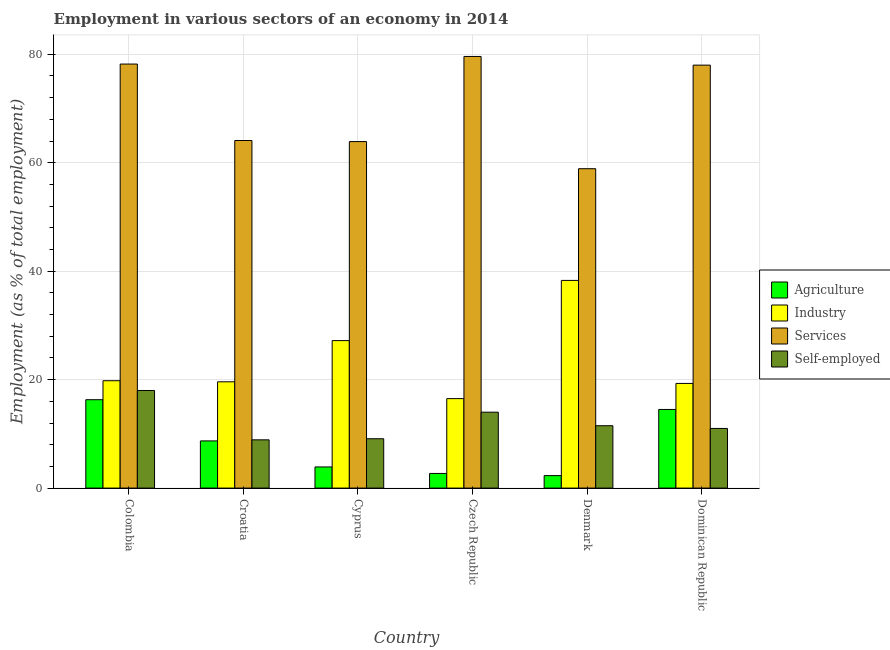How many groups of bars are there?
Provide a succinct answer. 6. Are the number of bars on each tick of the X-axis equal?
Make the answer very short. Yes. What is the label of the 3rd group of bars from the left?
Keep it short and to the point. Cyprus. In how many cases, is the number of bars for a given country not equal to the number of legend labels?
Keep it short and to the point. 0. Across all countries, what is the minimum percentage of workers in industry?
Your response must be concise. 16.5. In which country was the percentage of workers in agriculture maximum?
Make the answer very short. Colombia. In which country was the percentage of workers in industry minimum?
Provide a short and direct response. Czech Republic. What is the total percentage of workers in industry in the graph?
Offer a terse response. 140.7. What is the difference between the percentage of self employed workers in Cyprus and that in Denmark?
Make the answer very short. -2.4. What is the difference between the percentage of workers in services in Cyprus and the percentage of self employed workers in Czech Republic?
Make the answer very short. 49.9. What is the average percentage of workers in industry per country?
Offer a very short reply. 23.45. What is the difference between the percentage of self employed workers and percentage of workers in services in Czech Republic?
Your answer should be very brief. -65.6. In how many countries, is the percentage of workers in agriculture greater than 20 %?
Keep it short and to the point. 0. What is the ratio of the percentage of self employed workers in Cyprus to that in Czech Republic?
Offer a terse response. 0.65. Is the percentage of workers in industry in Czech Republic less than that in Dominican Republic?
Your answer should be compact. Yes. What is the difference between the highest and the second highest percentage of workers in agriculture?
Your response must be concise. 1.8. What is the difference between the highest and the lowest percentage of self employed workers?
Provide a short and direct response. 9.1. In how many countries, is the percentage of workers in services greater than the average percentage of workers in services taken over all countries?
Provide a succinct answer. 3. Is it the case that in every country, the sum of the percentage of workers in industry and percentage of workers in agriculture is greater than the sum of percentage of self employed workers and percentage of workers in services?
Provide a short and direct response. Yes. What does the 4th bar from the left in Denmark represents?
Offer a very short reply. Self-employed. What does the 4th bar from the right in Cyprus represents?
Your answer should be very brief. Agriculture. Is it the case that in every country, the sum of the percentage of workers in agriculture and percentage of workers in industry is greater than the percentage of workers in services?
Provide a succinct answer. No. How many bars are there?
Give a very brief answer. 24. Are all the bars in the graph horizontal?
Your answer should be very brief. No. How many countries are there in the graph?
Give a very brief answer. 6. What is the difference between two consecutive major ticks on the Y-axis?
Provide a succinct answer. 20. How many legend labels are there?
Keep it short and to the point. 4. How are the legend labels stacked?
Your answer should be compact. Vertical. What is the title of the graph?
Provide a succinct answer. Employment in various sectors of an economy in 2014. Does "UNPBF" appear as one of the legend labels in the graph?
Your response must be concise. No. What is the label or title of the X-axis?
Provide a short and direct response. Country. What is the label or title of the Y-axis?
Your response must be concise. Employment (as % of total employment). What is the Employment (as % of total employment) of Agriculture in Colombia?
Provide a succinct answer. 16.3. What is the Employment (as % of total employment) of Industry in Colombia?
Keep it short and to the point. 19.8. What is the Employment (as % of total employment) of Services in Colombia?
Your response must be concise. 78.2. What is the Employment (as % of total employment) in Self-employed in Colombia?
Offer a very short reply. 18. What is the Employment (as % of total employment) in Agriculture in Croatia?
Provide a succinct answer. 8.7. What is the Employment (as % of total employment) in Industry in Croatia?
Your answer should be very brief. 19.6. What is the Employment (as % of total employment) of Services in Croatia?
Give a very brief answer. 64.1. What is the Employment (as % of total employment) in Self-employed in Croatia?
Keep it short and to the point. 8.9. What is the Employment (as % of total employment) of Agriculture in Cyprus?
Make the answer very short. 3.9. What is the Employment (as % of total employment) in Industry in Cyprus?
Your response must be concise. 27.2. What is the Employment (as % of total employment) in Services in Cyprus?
Give a very brief answer. 63.9. What is the Employment (as % of total employment) of Self-employed in Cyprus?
Your answer should be very brief. 9.1. What is the Employment (as % of total employment) in Agriculture in Czech Republic?
Provide a succinct answer. 2.7. What is the Employment (as % of total employment) of Services in Czech Republic?
Give a very brief answer. 79.6. What is the Employment (as % of total employment) of Self-employed in Czech Republic?
Make the answer very short. 14. What is the Employment (as % of total employment) of Agriculture in Denmark?
Ensure brevity in your answer.  2.3. What is the Employment (as % of total employment) of Industry in Denmark?
Your response must be concise. 38.3. What is the Employment (as % of total employment) in Services in Denmark?
Offer a terse response. 58.9. What is the Employment (as % of total employment) in Self-employed in Denmark?
Your response must be concise. 11.5. What is the Employment (as % of total employment) of Industry in Dominican Republic?
Give a very brief answer. 19.3. What is the Employment (as % of total employment) of Services in Dominican Republic?
Your response must be concise. 78. What is the Employment (as % of total employment) of Self-employed in Dominican Republic?
Make the answer very short. 11. Across all countries, what is the maximum Employment (as % of total employment) of Agriculture?
Offer a terse response. 16.3. Across all countries, what is the maximum Employment (as % of total employment) of Industry?
Ensure brevity in your answer.  38.3. Across all countries, what is the maximum Employment (as % of total employment) of Services?
Your answer should be compact. 79.6. Across all countries, what is the maximum Employment (as % of total employment) in Self-employed?
Ensure brevity in your answer.  18. Across all countries, what is the minimum Employment (as % of total employment) in Agriculture?
Provide a short and direct response. 2.3. Across all countries, what is the minimum Employment (as % of total employment) in Services?
Your response must be concise. 58.9. Across all countries, what is the minimum Employment (as % of total employment) of Self-employed?
Give a very brief answer. 8.9. What is the total Employment (as % of total employment) of Agriculture in the graph?
Offer a very short reply. 48.4. What is the total Employment (as % of total employment) in Industry in the graph?
Your answer should be very brief. 140.7. What is the total Employment (as % of total employment) in Services in the graph?
Your response must be concise. 422.7. What is the total Employment (as % of total employment) of Self-employed in the graph?
Provide a short and direct response. 72.5. What is the difference between the Employment (as % of total employment) in Agriculture in Colombia and that in Croatia?
Offer a terse response. 7.6. What is the difference between the Employment (as % of total employment) of Agriculture in Colombia and that in Cyprus?
Give a very brief answer. 12.4. What is the difference between the Employment (as % of total employment) of Industry in Colombia and that in Cyprus?
Your response must be concise. -7.4. What is the difference between the Employment (as % of total employment) of Self-employed in Colombia and that in Cyprus?
Make the answer very short. 8.9. What is the difference between the Employment (as % of total employment) in Agriculture in Colombia and that in Czech Republic?
Make the answer very short. 13.6. What is the difference between the Employment (as % of total employment) of Services in Colombia and that in Czech Republic?
Provide a succinct answer. -1.4. What is the difference between the Employment (as % of total employment) in Agriculture in Colombia and that in Denmark?
Offer a terse response. 14. What is the difference between the Employment (as % of total employment) in Industry in Colombia and that in Denmark?
Provide a succinct answer. -18.5. What is the difference between the Employment (as % of total employment) in Services in Colombia and that in Denmark?
Keep it short and to the point. 19.3. What is the difference between the Employment (as % of total employment) of Agriculture in Colombia and that in Dominican Republic?
Provide a short and direct response. 1.8. What is the difference between the Employment (as % of total employment) in Industry in Colombia and that in Dominican Republic?
Make the answer very short. 0.5. What is the difference between the Employment (as % of total employment) of Self-employed in Colombia and that in Dominican Republic?
Your answer should be compact. 7. What is the difference between the Employment (as % of total employment) of Agriculture in Croatia and that in Cyprus?
Make the answer very short. 4.8. What is the difference between the Employment (as % of total employment) in Services in Croatia and that in Cyprus?
Provide a short and direct response. 0.2. What is the difference between the Employment (as % of total employment) of Self-employed in Croatia and that in Cyprus?
Provide a succinct answer. -0.2. What is the difference between the Employment (as % of total employment) of Services in Croatia and that in Czech Republic?
Provide a short and direct response. -15.5. What is the difference between the Employment (as % of total employment) of Self-employed in Croatia and that in Czech Republic?
Make the answer very short. -5.1. What is the difference between the Employment (as % of total employment) of Agriculture in Croatia and that in Denmark?
Offer a very short reply. 6.4. What is the difference between the Employment (as % of total employment) of Industry in Croatia and that in Denmark?
Offer a very short reply. -18.7. What is the difference between the Employment (as % of total employment) in Self-employed in Croatia and that in Denmark?
Provide a short and direct response. -2.6. What is the difference between the Employment (as % of total employment) of Agriculture in Cyprus and that in Czech Republic?
Keep it short and to the point. 1.2. What is the difference between the Employment (as % of total employment) in Industry in Cyprus and that in Czech Republic?
Provide a succinct answer. 10.7. What is the difference between the Employment (as % of total employment) of Services in Cyprus and that in Czech Republic?
Make the answer very short. -15.7. What is the difference between the Employment (as % of total employment) in Agriculture in Cyprus and that in Denmark?
Offer a very short reply. 1.6. What is the difference between the Employment (as % of total employment) in Services in Cyprus and that in Denmark?
Provide a succinct answer. 5. What is the difference between the Employment (as % of total employment) in Agriculture in Cyprus and that in Dominican Republic?
Your answer should be compact. -10.6. What is the difference between the Employment (as % of total employment) of Services in Cyprus and that in Dominican Republic?
Make the answer very short. -14.1. What is the difference between the Employment (as % of total employment) in Self-employed in Cyprus and that in Dominican Republic?
Offer a very short reply. -1.9. What is the difference between the Employment (as % of total employment) of Industry in Czech Republic and that in Denmark?
Your answer should be compact. -21.8. What is the difference between the Employment (as % of total employment) of Services in Czech Republic and that in Denmark?
Keep it short and to the point. 20.7. What is the difference between the Employment (as % of total employment) of Agriculture in Czech Republic and that in Dominican Republic?
Your answer should be very brief. -11.8. What is the difference between the Employment (as % of total employment) of Industry in Czech Republic and that in Dominican Republic?
Provide a succinct answer. -2.8. What is the difference between the Employment (as % of total employment) in Services in Czech Republic and that in Dominican Republic?
Provide a succinct answer. 1.6. What is the difference between the Employment (as % of total employment) in Self-employed in Czech Republic and that in Dominican Republic?
Keep it short and to the point. 3. What is the difference between the Employment (as % of total employment) in Agriculture in Denmark and that in Dominican Republic?
Keep it short and to the point. -12.2. What is the difference between the Employment (as % of total employment) in Services in Denmark and that in Dominican Republic?
Your answer should be very brief. -19.1. What is the difference between the Employment (as % of total employment) of Agriculture in Colombia and the Employment (as % of total employment) of Services in Croatia?
Give a very brief answer. -47.8. What is the difference between the Employment (as % of total employment) of Agriculture in Colombia and the Employment (as % of total employment) of Self-employed in Croatia?
Your answer should be compact. 7.4. What is the difference between the Employment (as % of total employment) of Industry in Colombia and the Employment (as % of total employment) of Services in Croatia?
Ensure brevity in your answer.  -44.3. What is the difference between the Employment (as % of total employment) in Industry in Colombia and the Employment (as % of total employment) in Self-employed in Croatia?
Provide a succinct answer. 10.9. What is the difference between the Employment (as % of total employment) of Services in Colombia and the Employment (as % of total employment) of Self-employed in Croatia?
Ensure brevity in your answer.  69.3. What is the difference between the Employment (as % of total employment) in Agriculture in Colombia and the Employment (as % of total employment) in Services in Cyprus?
Your response must be concise. -47.6. What is the difference between the Employment (as % of total employment) in Industry in Colombia and the Employment (as % of total employment) in Services in Cyprus?
Keep it short and to the point. -44.1. What is the difference between the Employment (as % of total employment) in Services in Colombia and the Employment (as % of total employment) in Self-employed in Cyprus?
Offer a very short reply. 69.1. What is the difference between the Employment (as % of total employment) of Agriculture in Colombia and the Employment (as % of total employment) of Industry in Czech Republic?
Your response must be concise. -0.2. What is the difference between the Employment (as % of total employment) in Agriculture in Colombia and the Employment (as % of total employment) in Services in Czech Republic?
Offer a terse response. -63.3. What is the difference between the Employment (as % of total employment) in Agriculture in Colombia and the Employment (as % of total employment) in Self-employed in Czech Republic?
Offer a terse response. 2.3. What is the difference between the Employment (as % of total employment) of Industry in Colombia and the Employment (as % of total employment) of Services in Czech Republic?
Offer a terse response. -59.8. What is the difference between the Employment (as % of total employment) in Services in Colombia and the Employment (as % of total employment) in Self-employed in Czech Republic?
Offer a very short reply. 64.2. What is the difference between the Employment (as % of total employment) of Agriculture in Colombia and the Employment (as % of total employment) of Services in Denmark?
Provide a succinct answer. -42.6. What is the difference between the Employment (as % of total employment) of Industry in Colombia and the Employment (as % of total employment) of Services in Denmark?
Keep it short and to the point. -39.1. What is the difference between the Employment (as % of total employment) of Industry in Colombia and the Employment (as % of total employment) of Self-employed in Denmark?
Ensure brevity in your answer.  8.3. What is the difference between the Employment (as % of total employment) in Services in Colombia and the Employment (as % of total employment) in Self-employed in Denmark?
Your answer should be compact. 66.7. What is the difference between the Employment (as % of total employment) of Agriculture in Colombia and the Employment (as % of total employment) of Services in Dominican Republic?
Provide a short and direct response. -61.7. What is the difference between the Employment (as % of total employment) in Agriculture in Colombia and the Employment (as % of total employment) in Self-employed in Dominican Republic?
Offer a terse response. 5.3. What is the difference between the Employment (as % of total employment) of Industry in Colombia and the Employment (as % of total employment) of Services in Dominican Republic?
Your response must be concise. -58.2. What is the difference between the Employment (as % of total employment) of Industry in Colombia and the Employment (as % of total employment) of Self-employed in Dominican Republic?
Provide a short and direct response. 8.8. What is the difference between the Employment (as % of total employment) in Services in Colombia and the Employment (as % of total employment) in Self-employed in Dominican Republic?
Your answer should be compact. 67.2. What is the difference between the Employment (as % of total employment) of Agriculture in Croatia and the Employment (as % of total employment) of Industry in Cyprus?
Your answer should be compact. -18.5. What is the difference between the Employment (as % of total employment) in Agriculture in Croatia and the Employment (as % of total employment) in Services in Cyprus?
Provide a short and direct response. -55.2. What is the difference between the Employment (as % of total employment) of Industry in Croatia and the Employment (as % of total employment) of Services in Cyprus?
Your response must be concise. -44.3. What is the difference between the Employment (as % of total employment) of Industry in Croatia and the Employment (as % of total employment) of Self-employed in Cyprus?
Your response must be concise. 10.5. What is the difference between the Employment (as % of total employment) of Services in Croatia and the Employment (as % of total employment) of Self-employed in Cyprus?
Provide a succinct answer. 55. What is the difference between the Employment (as % of total employment) of Agriculture in Croatia and the Employment (as % of total employment) of Services in Czech Republic?
Your response must be concise. -70.9. What is the difference between the Employment (as % of total employment) of Agriculture in Croatia and the Employment (as % of total employment) of Self-employed in Czech Republic?
Offer a very short reply. -5.3. What is the difference between the Employment (as % of total employment) in Industry in Croatia and the Employment (as % of total employment) in Services in Czech Republic?
Make the answer very short. -60. What is the difference between the Employment (as % of total employment) of Services in Croatia and the Employment (as % of total employment) of Self-employed in Czech Republic?
Offer a very short reply. 50.1. What is the difference between the Employment (as % of total employment) of Agriculture in Croatia and the Employment (as % of total employment) of Industry in Denmark?
Offer a very short reply. -29.6. What is the difference between the Employment (as % of total employment) of Agriculture in Croatia and the Employment (as % of total employment) of Services in Denmark?
Your answer should be compact. -50.2. What is the difference between the Employment (as % of total employment) of Agriculture in Croatia and the Employment (as % of total employment) of Self-employed in Denmark?
Your response must be concise. -2.8. What is the difference between the Employment (as % of total employment) in Industry in Croatia and the Employment (as % of total employment) in Services in Denmark?
Offer a very short reply. -39.3. What is the difference between the Employment (as % of total employment) in Industry in Croatia and the Employment (as % of total employment) in Self-employed in Denmark?
Provide a succinct answer. 8.1. What is the difference between the Employment (as % of total employment) of Services in Croatia and the Employment (as % of total employment) of Self-employed in Denmark?
Your answer should be compact. 52.6. What is the difference between the Employment (as % of total employment) of Agriculture in Croatia and the Employment (as % of total employment) of Industry in Dominican Republic?
Your response must be concise. -10.6. What is the difference between the Employment (as % of total employment) of Agriculture in Croatia and the Employment (as % of total employment) of Services in Dominican Republic?
Offer a terse response. -69.3. What is the difference between the Employment (as % of total employment) of Agriculture in Croatia and the Employment (as % of total employment) of Self-employed in Dominican Republic?
Make the answer very short. -2.3. What is the difference between the Employment (as % of total employment) in Industry in Croatia and the Employment (as % of total employment) in Services in Dominican Republic?
Make the answer very short. -58.4. What is the difference between the Employment (as % of total employment) of Industry in Croatia and the Employment (as % of total employment) of Self-employed in Dominican Republic?
Your response must be concise. 8.6. What is the difference between the Employment (as % of total employment) in Services in Croatia and the Employment (as % of total employment) in Self-employed in Dominican Republic?
Your response must be concise. 53.1. What is the difference between the Employment (as % of total employment) of Agriculture in Cyprus and the Employment (as % of total employment) of Industry in Czech Republic?
Your response must be concise. -12.6. What is the difference between the Employment (as % of total employment) of Agriculture in Cyprus and the Employment (as % of total employment) of Services in Czech Republic?
Your answer should be compact. -75.7. What is the difference between the Employment (as % of total employment) of Agriculture in Cyprus and the Employment (as % of total employment) of Self-employed in Czech Republic?
Offer a terse response. -10.1. What is the difference between the Employment (as % of total employment) of Industry in Cyprus and the Employment (as % of total employment) of Services in Czech Republic?
Provide a succinct answer. -52.4. What is the difference between the Employment (as % of total employment) of Services in Cyprus and the Employment (as % of total employment) of Self-employed in Czech Republic?
Offer a very short reply. 49.9. What is the difference between the Employment (as % of total employment) in Agriculture in Cyprus and the Employment (as % of total employment) in Industry in Denmark?
Keep it short and to the point. -34.4. What is the difference between the Employment (as % of total employment) of Agriculture in Cyprus and the Employment (as % of total employment) of Services in Denmark?
Your response must be concise. -55. What is the difference between the Employment (as % of total employment) of Agriculture in Cyprus and the Employment (as % of total employment) of Self-employed in Denmark?
Your answer should be very brief. -7.6. What is the difference between the Employment (as % of total employment) in Industry in Cyprus and the Employment (as % of total employment) in Services in Denmark?
Make the answer very short. -31.7. What is the difference between the Employment (as % of total employment) in Industry in Cyprus and the Employment (as % of total employment) in Self-employed in Denmark?
Your response must be concise. 15.7. What is the difference between the Employment (as % of total employment) in Services in Cyprus and the Employment (as % of total employment) in Self-employed in Denmark?
Your answer should be very brief. 52.4. What is the difference between the Employment (as % of total employment) in Agriculture in Cyprus and the Employment (as % of total employment) in Industry in Dominican Republic?
Ensure brevity in your answer.  -15.4. What is the difference between the Employment (as % of total employment) in Agriculture in Cyprus and the Employment (as % of total employment) in Services in Dominican Republic?
Your response must be concise. -74.1. What is the difference between the Employment (as % of total employment) of Agriculture in Cyprus and the Employment (as % of total employment) of Self-employed in Dominican Republic?
Give a very brief answer. -7.1. What is the difference between the Employment (as % of total employment) of Industry in Cyprus and the Employment (as % of total employment) of Services in Dominican Republic?
Provide a succinct answer. -50.8. What is the difference between the Employment (as % of total employment) of Industry in Cyprus and the Employment (as % of total employment) of Self-employed in Dominican Republic?
Make the answer very short. 16.2. What is the difference between the Employment (as % of total employment) in Services in Cyprus and the Employment (as % of total employment) in Self-employed in Dominican Republic?
Your answer should be very brief. 52.9. What is the difference between the Employment (as % of total employment) of Agriculture in Czech Republic and the Employment (as % of total employment) of Industry in Denmark?
Keep it short and to the point. -35.6. What is the difference between the Employment (as % of total employment) of Agriculture in Czech Republic and the Employment (as % of total employment) of Services in Denmark?
Your answer should be compact. -56.2. What is the difference between the Employment (as % of total employment) in Industry in Czech Republic and the Employment (as % of total employment) in Services in Denmark?
Provide a succinct answer. -42.4. What is the difference between the Employment (as % of total employment) of Services in Czech Republic and the Employment (as % of total employment) of Self-employed in Denmark?
Provide a succinct answer. 68.1. What is the difference between the Employment (as % of total employment) of Agriculture in Czech Republic and the Employment (as % of total employment) of Industry in Dominican Republic?
Keep it short and to the point. -16.6. What is the difference between the Employment (as % of total employment) in Agriculture in Czech Republic and the Employment (as % of total employment) in Services in Dominican Republic?
Give a very brief answer. -75.3. What is the difference between the Employment (as % of total employment) of Industry in Czech Republic and the Employment (as % of total employment) of Services in Dominican Republic?
Provide a short and direct response. -61.5. What is the difference between the Employment (as % of total employment) in Industry in Czech Republic and the Employment (as % of total employment) in Self-employed in Dominican Republic?
Keep it short and to the point. 5.5. What is the difference between the Employment (as % of total employment) of Services in Czech Republic and the Employment (as % of total employment) of Self-employed in Dominican Republic?
Offer a very short reply. 68.6. What is the difference between the Employment (as % of total employment) of Agriculture in Denmark and the Employment (as % of total employment) of Services in Dominican Republic?
Give a very brief answer. -75.7. What is the difference between the Employment (as % of total employment) of Agriculture in Denmark and the Employment (as % of total employment) of Self-employed in Dominican Republic?
Provide a succinct answer. -8.7. What is the difference between the Employment (as % of total employment) of Industry in Denmark and the Employment (as % of total employment) of Services in Dominican Republic?
Give a very brief answer. -39.7. What is the difference between the Employment (as % of total employment) of Industry in Denmark and the Employment (as % of total employment) of Self-employed in Dominican Republic?
Offer a very short reply. 27.3. What is the difference between the Employment (as % of total employment) of Services in Denmark and the Employment (as % of total employment) of Self-employed in Dominican Republic?
Your response must be concise. 47.9. What is the average Employment (as % of total employment) in Agriculture per country?
Your answer should be compact. 8.07. What is the average Employment (as % of total employment) in Industry per country?
Provide a succinct answer. 23.45. What is the average Employment (as % of total employment) of Services per country?
Your answer should be compact. 70.45. What is the average Employment (as % of total employment) in Self-employed per country?
Your answer should be compact. 12.08. What is the difference between the Employment (as % of total employment) in Agriculture and Employment (as % of total employment) in Industry in Colombia?
Your response must be concise. -3.5. What is the difference between the Employment (as % of total employment) of Agriculture and Employment (as % of total employment) of Services in Colombia?
Offer a very short reply. -61.9. What is the difference between the Employment (as % of total employment) of Agriculture and Employment (as % of total employment) of Self-employed in Colombia?
Your answer should be very brief. -1.7. What is the difference between the Employment (as % of total employment) of Industry and Employment (as % of total employment) of Services in Colombia?
Your answer should be very brief. -58.4. What is the difference between the Employment (as % of total employment) in Services and Employment (as % of total employment) in Self-employed in Colombia?
Ensure brevity in your answer.  60.2. What is the difference between the Employment (as % of total employment) in Agriculture and Employment (as % of total employment) in Industry in Croatia?
Your answer should be very brief. -10.9. What is the difference between the Employment (as % of total employment) of Agriculture and Employment (as % of total employment) of Services in Croatia?
Your response must be concise. -55.4. What is the difference between the Employment (as % of total employment) in Industry and Employment (as % of total employment) in Services in Croatia?
Provide a succinct answer. -44.5. What is the difference between the Employment (as % of total employment) in Industry and Employment (as % of total employment) in Self-employed in Croatia?
Offer a very short reply. 10.7. What is the difference between the Employment (as % of total employment) in Services and Employment (as % of total employment) in Self-employed in Croatia?
Your response must be concise. 55.2. What is the difference between the Employment (as % of total employment) in Agriculture and Employment (as % of total employment) in Industry in Cyprus?
Offer a very short reply. -23.3. What is the difference between the Employment (as % of total employment) of Agriculture and Employment (as % of total employment) of Services in Cyprus?
Offer a very short reply. -60. What is the difference between the Employment (as % of total employment) of Industry and Employment (as % of total employment) of Services in Cyprus?
Offer a terse response. -36.7. What is the difference between the Employment (as % of total employment) in Industry and Employment (as % of total employment) in Self-employed in Cyprus?
Your answer should be very brief. 18.1. What is the difference between the Employment (as % of total employment) of Services and Employment (as % of total employment) of Self-employed in Cyprus?
Your response must be concise. 54.8. What is the difference between the Employment (as % of total employment) in Agriculture and Employment (as % of total employment) in Services in Czech Republic?
Provide a short and direct response. -76.9. What is the difference between the Employment (as % of total employment) of Industry and Employment (as % of total employment) of Services in Czech Republic?
Ensure brevity in your answer.  -63.1. What is the difference between the Employment (as % of total employment) in Industry and Employment (as % of total employment) in Self-employed in Czech Republic?
Your answer should be compact. 2.5. What is the difference between the Employment (as % of total employment) in Services and Employment (as % of total employment) in Self-employed in Czech Republic?
Ensure brevity in your answer.  65.6. What is the difference between the Employment (as % of total employment) in Agriculture and Employment (as % of total employment) in Industry in Denmark?
Your answer should be very brief. -36. What is the difference between the Employment (as % of total employment) in Agriculture and Employment (as % of total employment) in Services in Denmark?
Your answer should be very brief. -56.6. What is the difference between the Employment (as % of total employment) in Agriculture and Employment (as % of total employment) in Self-employed in Denmark?
Your answer should be compact. -9.2. What is the difference between the Employment (as % of total employment) in Industry and Employment (as % of total employment) in Services in Denmark?
Your answer should be very brief. -20.6. What is the difference between the Employment (as % of total employment) of Industry and Employment (as % of total employment) of Self-employed in Denmark?
Your response must be concise. 26.8. What is the difference between the Employment (as % of total employment) in Services and Employment (as % of total employment) in Self-employed in Denmark?
Make the answer very short. 47.4. What is the difference between the Employment (as % of total employment) of Agriculture and Employment (as % of total employment) of Services in Dominican Republic?
Make the answer very short. -63.5. What is the difference between the Employment (as % of total employment) of Industry and Employment (as % of total employment) of Services in Dominican Republic?
Your answer should be very brief. -58.7. What is the ratio of the Employment (as % of total employment) of Agriculture in Colombia to that in Croatia?
Provide a short and direct response. 1.87. What is the ratio of the Employment (as % of total employment) of Industry in Colombia to that in Croatia?
Make the answer very short. 1.01. What is the ratio of the Employment (as % of total employment) of Services in Colombia to that in Croatia?
Provide a short and direct response. 1.22. What is the ratio of the Employment (as % of total employment) of Self-employed in Colombia to that in Croatia?
Keep it short and to the point. 2.02. What is the ratio of the Employment (as % of total employment) of Agriculture in Colombia to that in Cyprus?
Provide a succinct answer. 4.18. What is the ratio of the Employment (as % of total employment) of Industry in Colombia to that in Cyprus?
Make the answer very short. 0.73. What is the ratio of the Employment (as % of total employment) in Services in Colombia to that in Cyprus?
Make the answer very short. 1.22. What is the ratio of the Employment (as % of total employment) in Self-employed in Colombia to that in Cyprus?
Give a very brief answer. 1.98. What is the ratio of the Employment (as % of total employment) of Agriculture in Colombia to that in Czech Republic?
Keep it short and to the point. 6.04. What is the ratio of the Employment (as % of total employment) in Industry in Colombia to that in Czech Republic?
Provide a succinct answer. 1.2. What is the ratio of the Employment (as % of total employment) in Services in Colombia to that in Czech Republic?
Provide a succinct answer. 0.98. What is the ratio of the Employment (as % of total employment) of Agriculture in Colombia to that in Denmark?
Make the answer very short. 7.09. What is the ratio of the Employment (as % of total employment) in Industry in Colombia to that in Denmark?
Give a very brief answer. 0.52. What is the ratio of the Employment (as % of total employment) in Services in Colombia to that in Denmark?
Provide a short and direct response. 1.33. What is the ratio of the Employment (as % of total employment) of Self-employed in Colombia to that in Denmark?
Ensure brevity in your answer.  1.57. What is the ratio of the Employment (as % of total employment) in Agriculture in Colombia to that in Dominican Republic?
Your answer should be compact. 1.12. What is the ratio of the Employment (as % of total employment) of Industry in Colombia to that in Dominican Republic?
Offer a very short reply. 1.03. What is the ratio of the Employment (as % of total employment) of Services in Colombia to that in Dominican Republic?
Your answer should be very brief. 1. What is the ratio of the Employment (as % of total employment) in Self-employed in Colombia to that in Dominican Republic?
Your response must be concise. 1.64. What is the ratio of the Employment (as % of total employment) of Agriculture in Croatia to that in Cyprus?
Your response must be concise. 2.23. What is the ratio of the Employment (as % of total employment) of Industry in Croatia to that in Cyprus?
Keep it short and to the point. 0.72. What is the ratio of the Employment (as % of total employment) in Services in Croatia to that in Cyprus?
Make the answer very short. 1. What is the ratio of the Employment (as % of total employment) of Self-employed in Croatia to that in Cyprus?
Keep it short and to the point. 0.98. What is the ratio of the Employment (as % of total employment) in Agriculture in Croatia to that in Czech Republic?
Provide a short and direct response. 3.22. What is the ratio of the Employment (as % of total employment) of Industry in Croatia to that in Czech Republic?
Offer a very short reply. 1.19. What is the ratio of the Employment (as % of total employment) of Services in Croatia to that in Czech Republic?
Offer a terse response. 0.81. What is the ratio of the Employment (as % of total employment) in Self-employed in Croatia to that in Czech Republic?
Give a very brief answer. 0.64. What is the ratio of the Employment (as % of total employment) in Agriculture in Croatia to that in Denmark?
Offer a terse response. 3.78. What is the ratio of the Employment (as % of total employment) in Industry in Croatia to that in Denmark?
Make the answer very short. 0.51. What is the ratio of the Employment (as % of total employment) of Services in Croatia to that in Denmark?
Ensure brevity in your answer.  1.09. What is the ratio of the Employment (as % of total employment) of Self-employed in Croatia to that in Denmark?
Your response must be concise. 0.77. What is the ratio of the Employment (as % of total employment) of Agriculture in Croatia to that in Dominican Republic?
Make the answer very short. 0.6. What is the ratio of the Employment (as % of total employment) of Industry in Croatia to that in Dominican Republic?
Your answer should be very brief. 1.02. What is the ratio of the Employment (as % of total employment) of Services in Croatia to that in Dominican Republic?
Offer a terse response. 0.82. What is the ratio of the Employment (as % of total employment) in Self-employed in Croatia to that in Dominican Republic?
Ensure brevity in your answer.  0.81. What is the ratio of the Employment (as % of total employment) in Agriculture in Cyprus to that in Czech Republic?
Ensure brevity in your answer.  1.44. What is the ratio of the Employment (as % of total employment) of Industry in Cyprus to that in Czech Republic?
Make the answer very short. 1.65. What is the ratio of the Employment (as % of total employment) in Services in Cyprus to that in Czech Republic?
Your answer should be very brief. 0.8. What is the ratio of the Employment (as % of total employment) of Self-employed in Cyprus to that in Czech Republic?
Provide a succinct answer. 0.65. What is the ratio of the Employment (as % of total employment) in Agriculture in Cyprus to that in Denmark?
Offer a very short reply. 1.7. What is the ratio of the Employment (as % of total employment) of Industry in Cyprus to that in Denmark?
Keep it short and to the point. 0.71. What is the ratio of the Employment (as % of total employment) in Services in Cyprus to that in Denmark?
Your response must be concise. 1.08. What is the ratio of the Employment (as % of total employment) in Self-employed in Cyprus to that in Denmark?
Keep it short and to the point. 0.79. What is the ratio of the Employment (as % of total employment) in Agriculture in Cyprus to that in Dominican Republic?
Your answer should be compact. 0.27. What is the ratio of the Employment (as % of total employment) of Industry in Cyprus to that in Dominican Republic?
Your answer should be compact. 1.41. What is the ratio of the Employment (as % of total employment) of Services in Cyprus to that in Dominican Republic?
Keep it short and to the point. 0.82. What is the ratio of the Employment (as % of total employment) of Self-employed in Cyprus to that in Dominican Republic?
Offer a terse response. 0.83. What is the ratio of the Employment (as % of total employment) of Agriculture in Czech Republic to that in Denmark?
Provide a succinct answer. 1.17. What is the ratio of the Employment (as % of total employment) in Industry in Czech Republic to that in Denmark?
Offer a very short reply. 0.43. What is the ratio of the Employment (as % of total employment) of Services in Czech Republic to that in Denmark?
Give a very brief answer. 1.35. What is the ratio of the Employment (as % of total employment) in Self-employed in Czech Republic to that in Denmark?
Make the answer very short. 1.22. What is the ratio of the Employment (as % of total employment) of Agriculture in Czech Republic to that in Dominican Republic?
Your answer should be compact. 0.19. What is the ratio of the Employment (as % of total employment) in Industry in Czech Republic to that in Dominican Republic?
Keep it short and to the point. 0.85. What is the ratio of the Employment (as % of total employment) in Services in Czech Republic to that in Dominican Republic?
Offer a terse response. 1.02. What is the ratio of the Employment (as % of total employment) of Self-employed in Czech Republic to that in Dominican Republic?
Keep it short and to the point. 1.27. What is the ratio of the Employment (as % of total employment) of Agriculture in Denmark to that in Dominican Republic?
Provide a short and direct response. 0.16. What is the ratio of the Employment (as % of total employment) in Industry in Denmark to that in Dominican Republic?
Ensure brevity in your answer.  1.98. What is the ratio of the Employment (as % of total employment) in Services in Denmark to that in Dominican Republic?
Ensure brevity in your answer.  0.76. What is the ratio of the Employment (as % of total employment) in Self-employed in Denmark to that in Dominican Republic?
Offer a very short reply. 1.05. What is the difference between the highest and the second highest Employment (as % of total employment) in Agriculture?
Make the answer very short. 1.8. What is the difference between the highest and the second highest Employment (as % of total employment) of Industry?
Make the answer very short. 11.1. What is the difference between the highest and the lowest Employment (as % of total employment) of Agriculture?
Keep it short and to the point. 14. What is the difference between the highest and the lowest Employment (as % of total employment) of Industry?
Make the answer very short. 21.8. What is the difference between the highest and the lowest Employment (as % of total employment) in Services?
Make the answer very short. 20.7. What is the difference between the highest and the lowest Employment (as % of total employment) of Self-employed?
Offer a terse response. 9.1. 